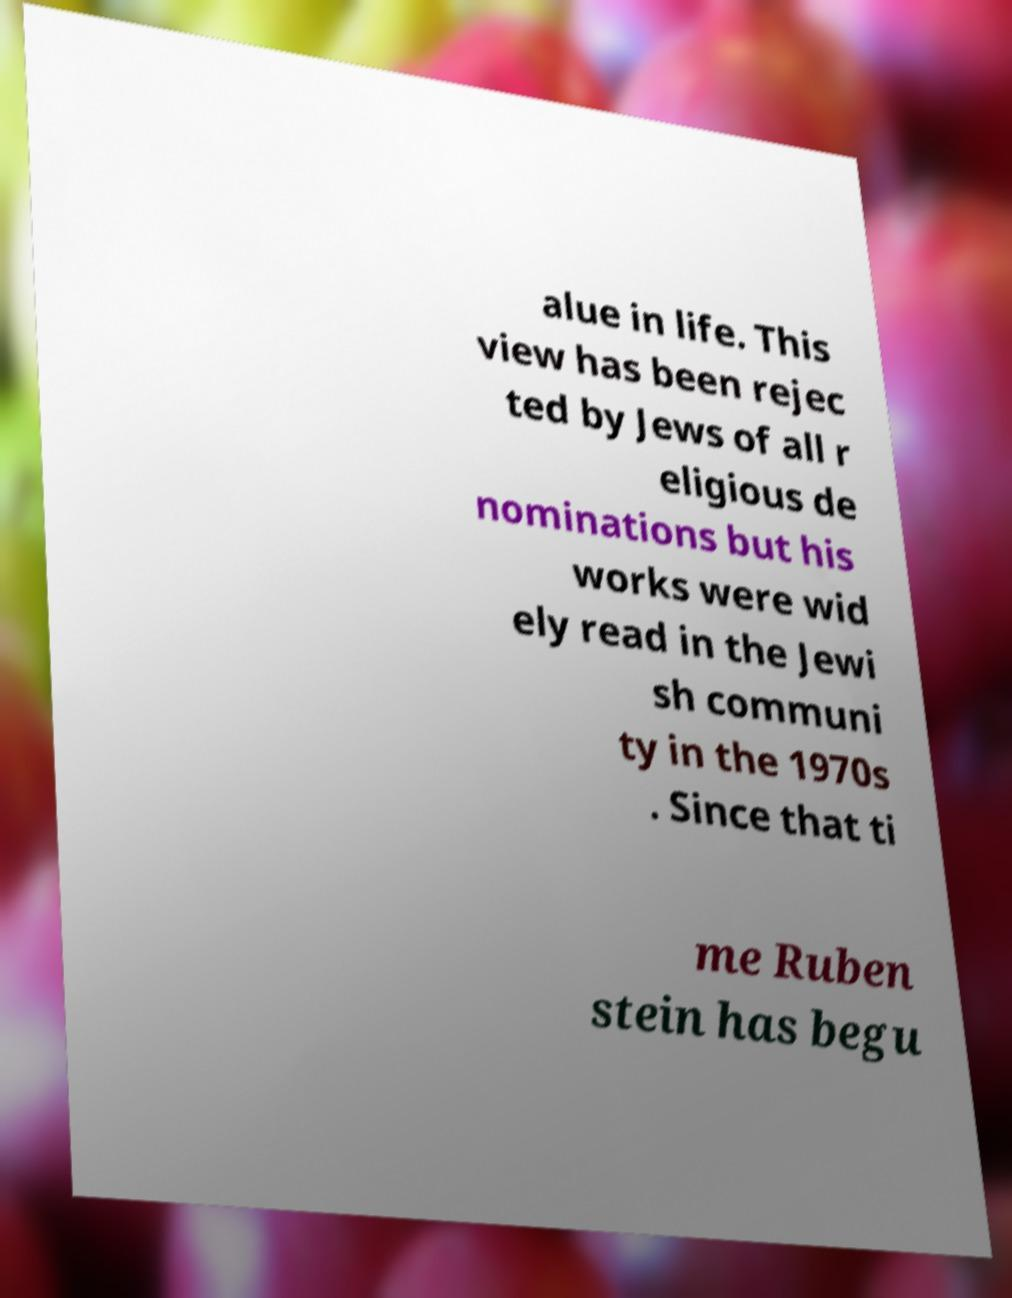There's text embedded in this image that I need extracted. Can you transcribe it verbatim? alue in life. This view has been rejec ted by Jews of all r eligious de nominations but his works were wid ely read in the Jewi sh communi ty in the 1970s . Since that ti me Ruben stein has begu 